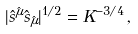Convert formula to latex. <formula><loc_0><loc_0><loc_500><loc_500>| \hat { s } ^ { \hat { \mu } } \hat { s } _ { \hat { \mu } } | ^ { 1 / 2 } = K ^ { - 3 / 4 } \, ,</formula> 